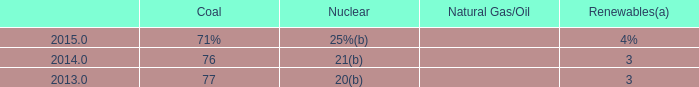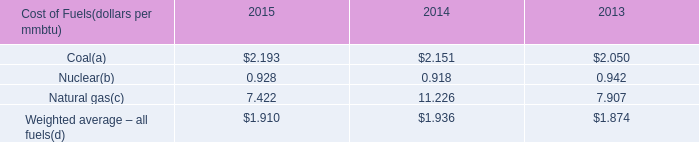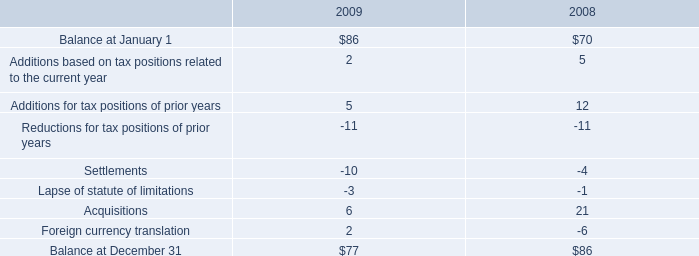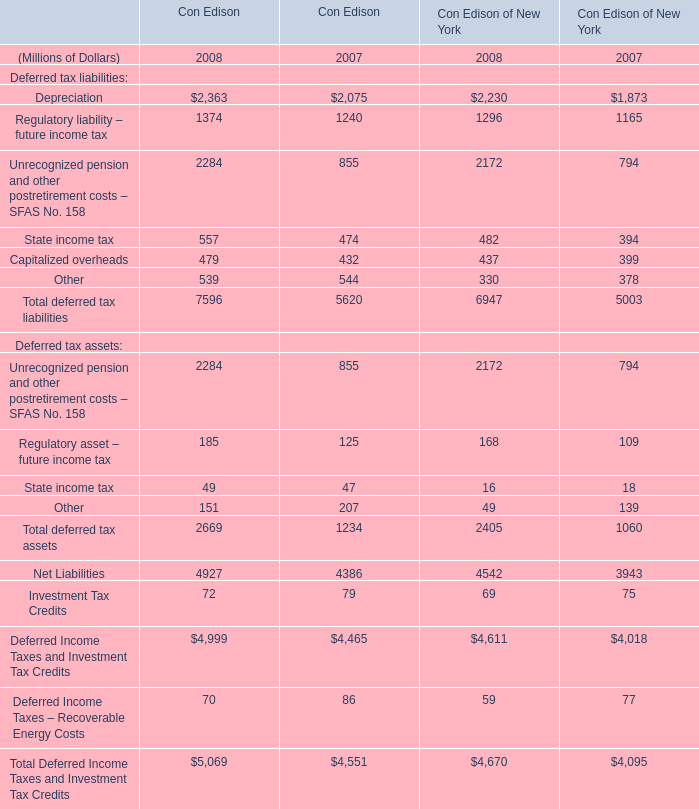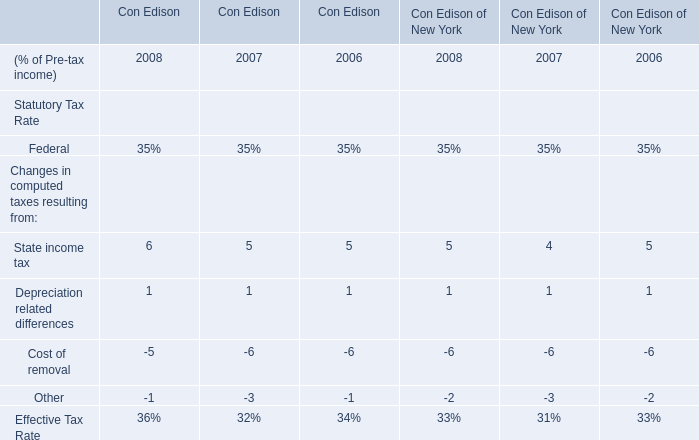Is the total amount of all elements in 2008 greater than that in 2007? 
Answer: yes. 